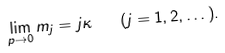<formula> <loc_0><loc_0><loc_500><loc_500>\lim _ { p \to 0 } m _ { j } = j \kappa \quad ( j = 1 , 2 , \dots ) .</formula> 